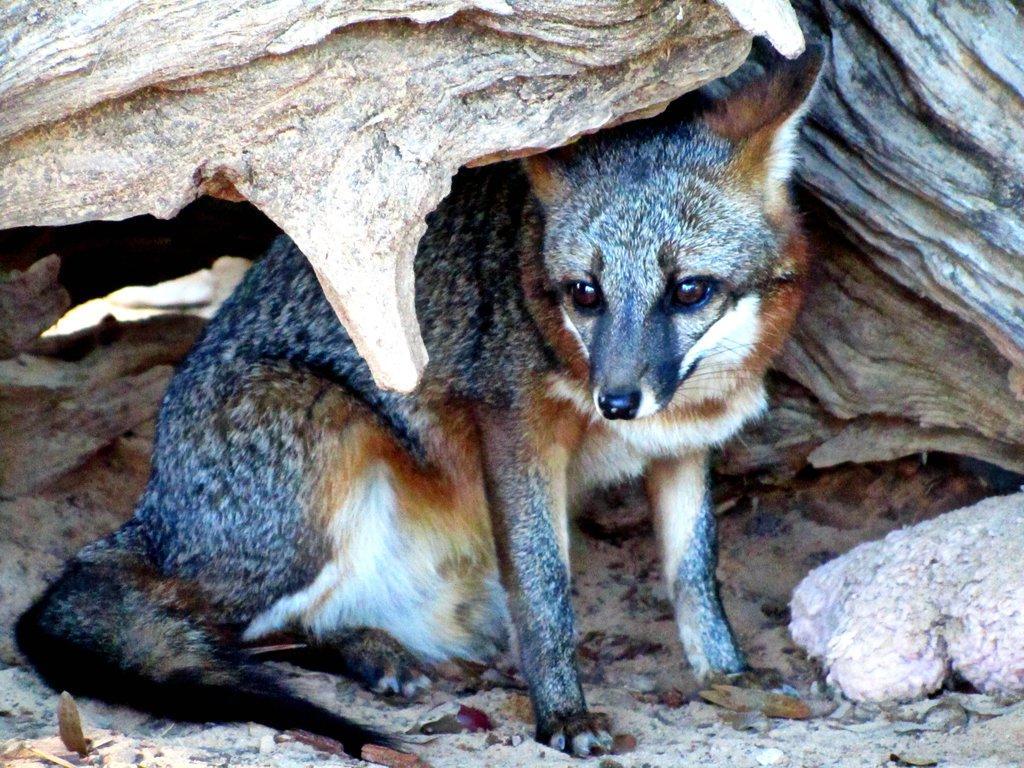Describe this image in one or two sentences. In this image I can see an animal in brown, white and cream color. In the background I can see an object in brown and cream color. 